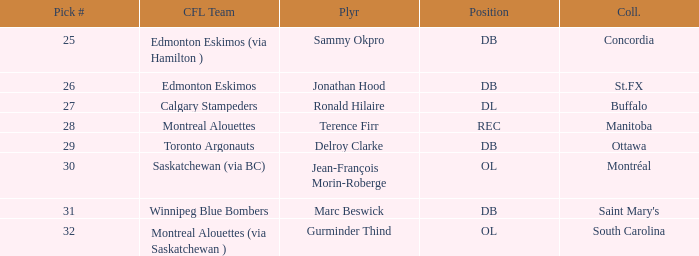Help me parse the entirety of this table. {'header': ['Pick #', 'CFL Team', 'Plyr', 'Position', 'Coll.'], 'rows': [['25', 'Edmonton Eskimos (via Hamilton )', 'Sammy Okpro', 'DB', 'Concordia'], ['26', 'Edmonton Eskimos', 'Jonathan Hood', 'DB', 'St.FX'], ['27', 'Calgary Stampeders', 'Ronald Hilaire', 'DL', 'Buffalo'], ['28', 'Montreal Alouettes', 'Terence Firr', 'REC', 'Manitoba'], ['29', 'Toronto Argonauts', 'Delroy Clarke', 'DB', 'Ottawa'], ['30', 'Saskatchewan (via BC)', 'Jean-François Morin-Roberge', 'OL', 'Montréal'], ['31', 'Winnipeg Blue Bombers', 'Marc Beswick', 'DB', "Saint Mary's"], ['32', 'Montreal Alouettes (via Saskatchewan )', 'Gurminder Thind', 'OL', 'South Carolina']]} Which Pick # has a College of concordia? 25.0. 